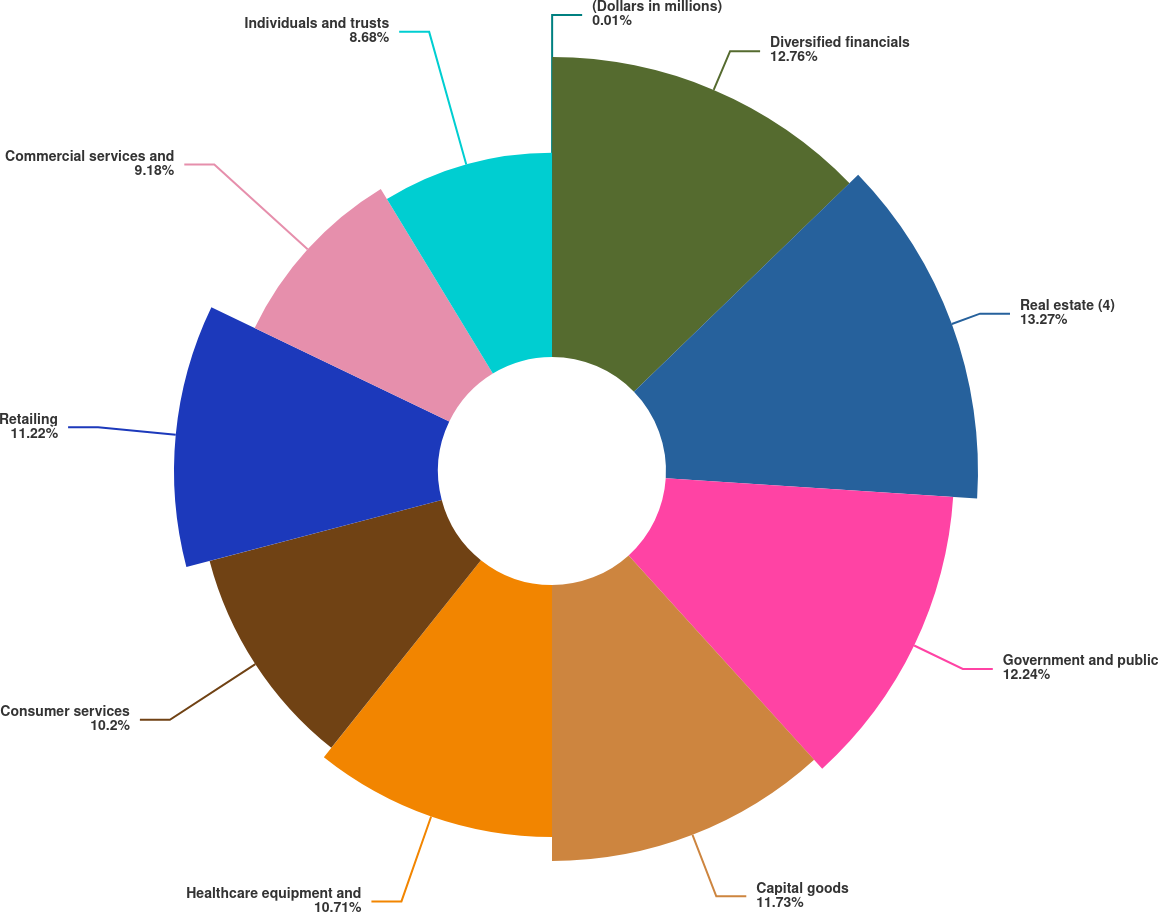Convert chart to OTSL. <chart><loc_0><loc_0><loc_500><loc_500><pie_chart><fcel>(Dollars in millions)<fcel>Diversified financials<fcel>Real estate (4)<fcel>Government and public<fcel>Capital goods<fcel>Healthcare equipment and<fcel>Consumer services<fcel>Retailing<fcel>Commercial services and<fcel>Individuals and trusts<nl><fcel>0.01%<fcel>12.75%<fcel>13.26%<fcel>12.24%<fcel>11.73%<fcel>10.71%<fcel>10.2%<fcel>11.22%<fcel>9.18%<fcel>8.68%<nl></chart> 